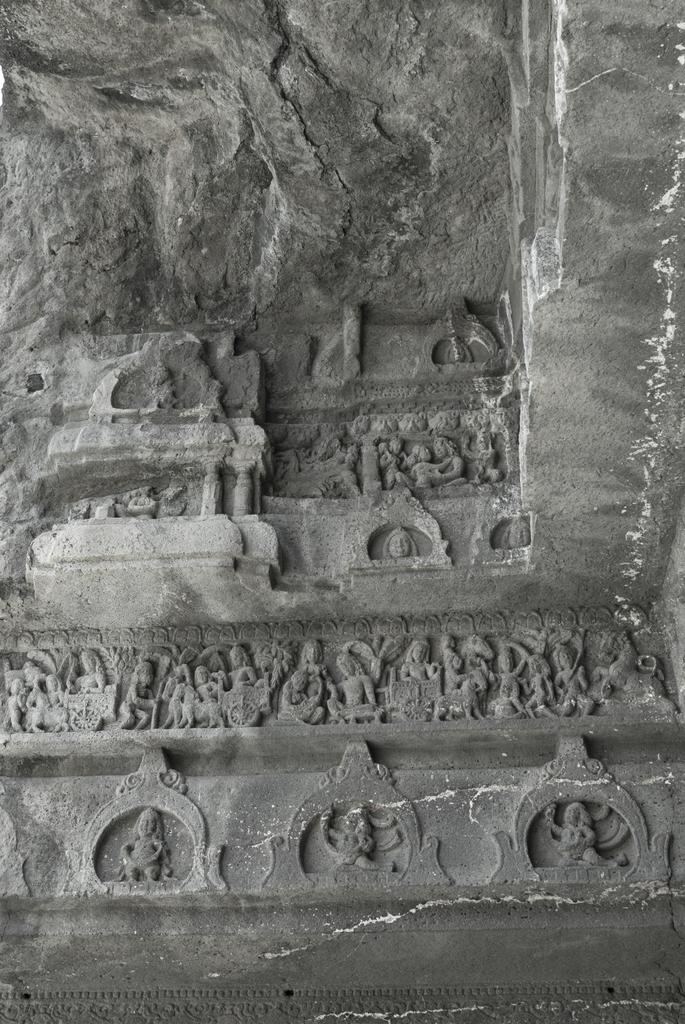What is present on the wall in the image? Sculptures are carved on the wall in the image. Can you describe the sculptures on the wall? The sculptures are carved directly onto the wall. What type of metal is used to create the haircut sculpture on the wall? There is no haircut sculpture present on the wall in the image, and no mention of metal. 